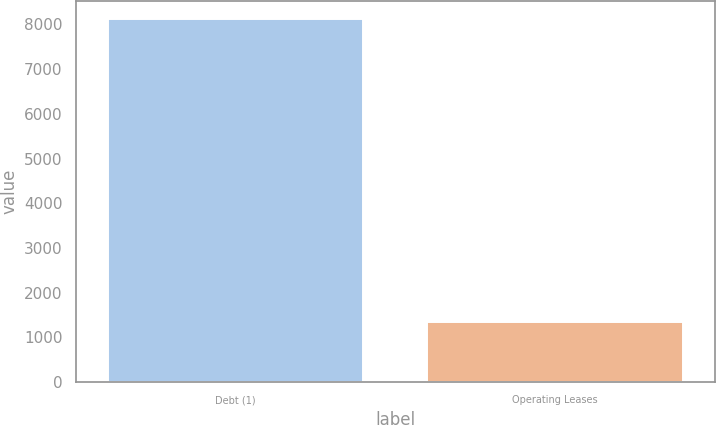<chart> <loc_0><loc_0><loc_500><loc_500><bar_chart><fcel>Debt (1)<fcel>Operating Leases<nl><fcel>8112<fcel>1334<nl></chart> 